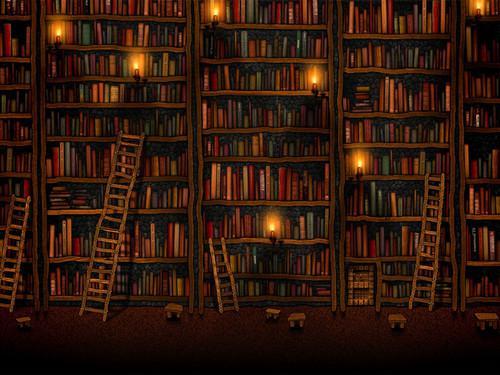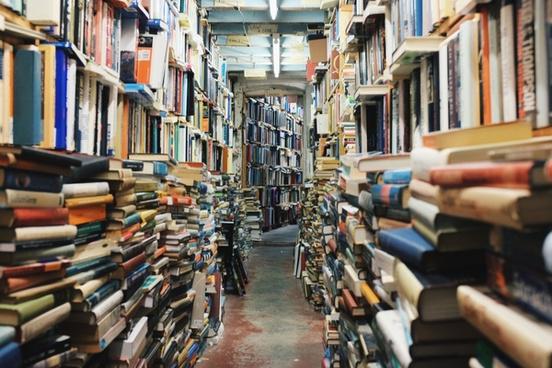The first image is the image on the left, the second image is the image on the right. Analyze the images presented: Is the assertion "There is a person looking at a book." valid? Answer yes or no. No. The first image is the image on the left, the second image is the image on the right. Given the left and right images, does the statement "Both images show large collections of books and no people can be seen in either." hold true? Answer yes or no. Yes. 